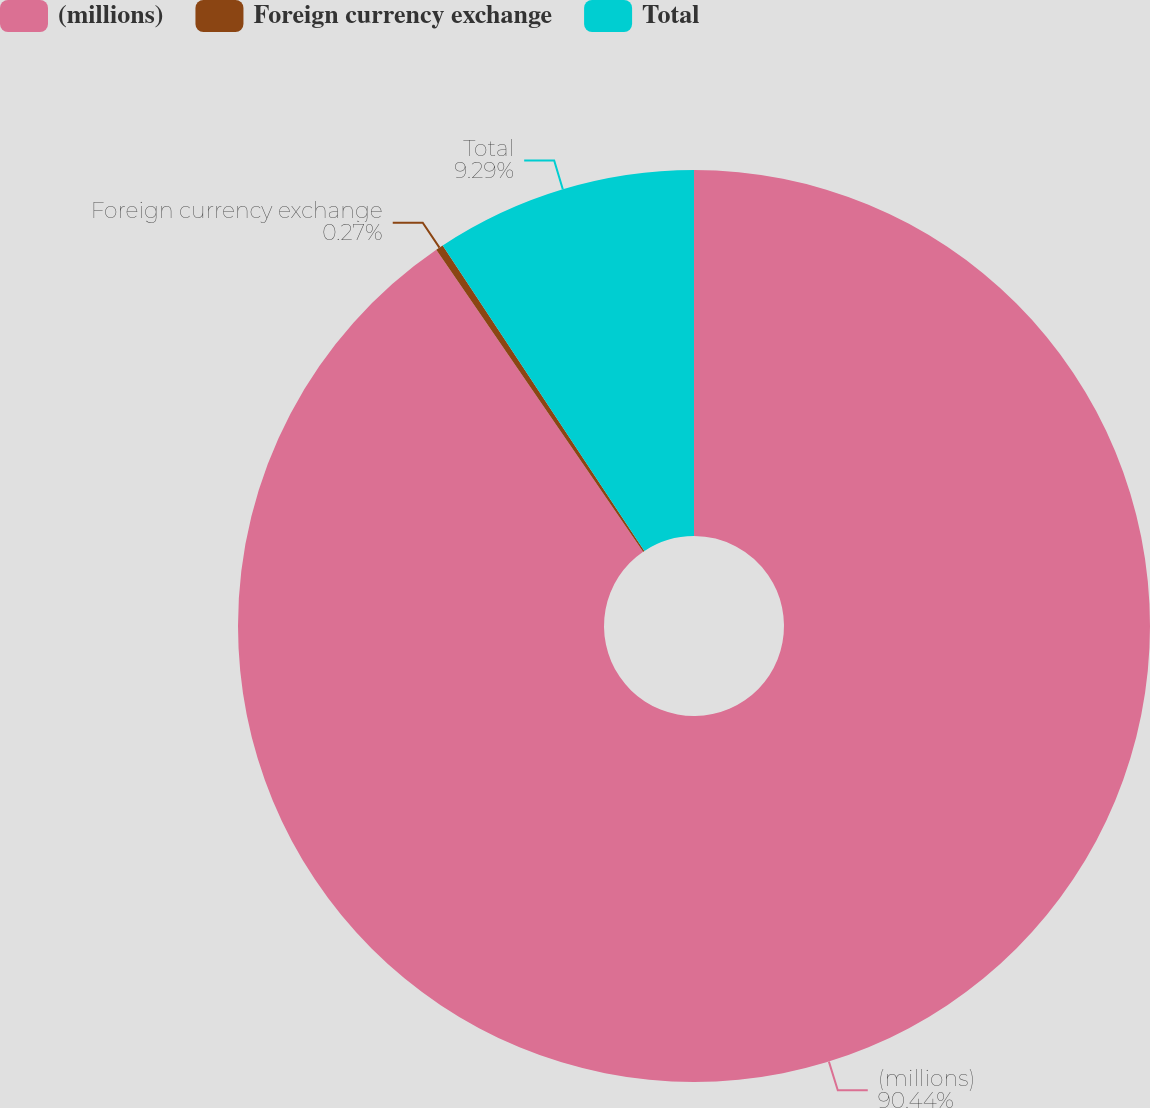Convert chart to OTSL. <chart><loc_0><loc_0><loc_500><loc_500><pie_chart><fcel>(millions)<fcel>Foreign currency exchange<fcel>Total<nl><fcel>90.44%<fcel>0.27%<fcel>9.29%<nl></chart> 